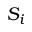<formula> <loc_0><loc_0><loc_500><loc_500>S _ { i }</formula> 